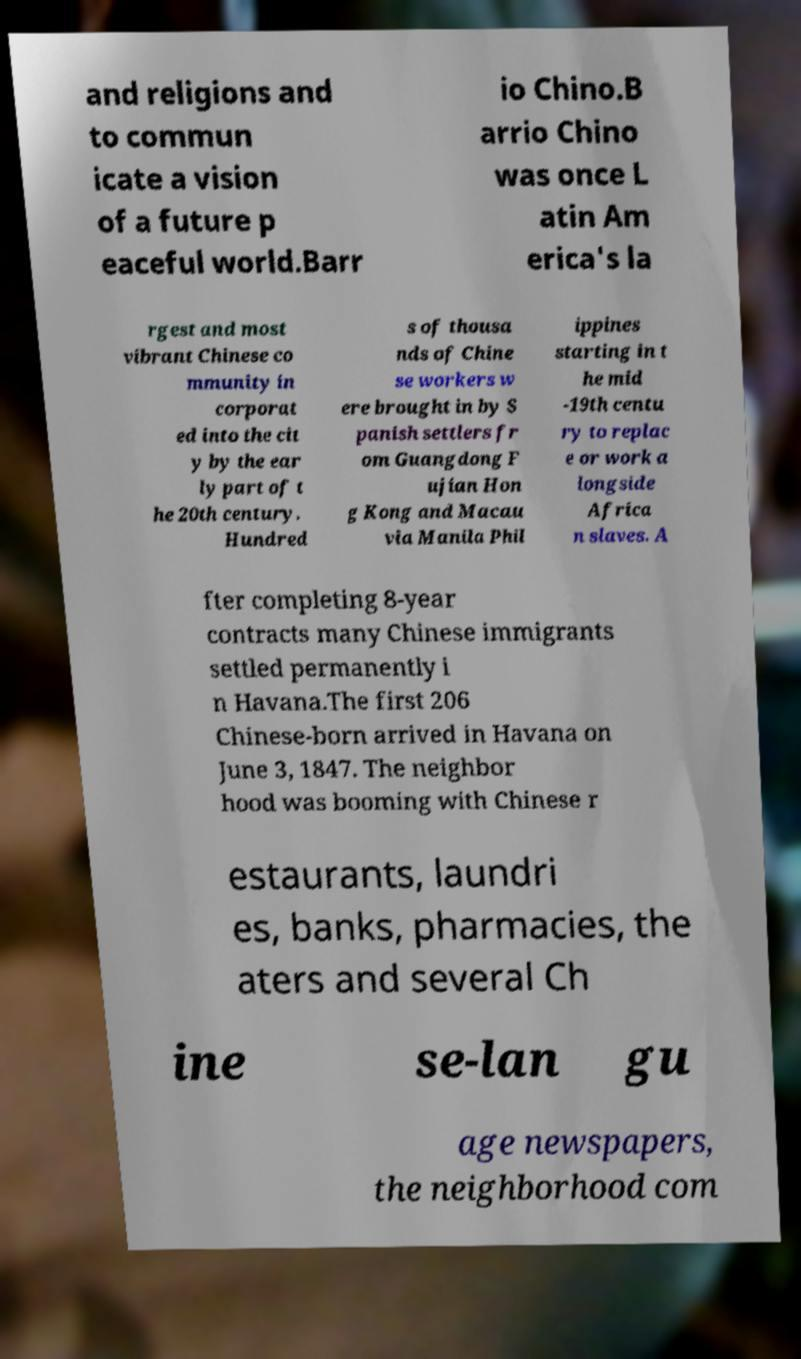I need the written content from this picture converted into text. Can you do that? and religions and to commun icate a vision of a future p eaceful world.Barr io Chino.B arrio Chino was once L atin Am erica's la rgest and most vibrant Chinese co mmunity in corporat ed into the cit y by the ear ly part of t he 20th century. Hundred s of thousa nds of Chine se workers w ere brought in by S panish settlers fr om Guangdong F ujian Hon g Kong and Macau via Manila Phil ippines starting in t he mid -19th centu ry to replac e or work a longside Africa n slaves. A fter completing 8-year contracts many Chinese immigrants settled permanently i n Havana.The first 206 Chinese-born arrived in Havana on June 3, 1847. The neighbor hood was booming with Chinese r estaurants, laundri es, banks, pharmacies, the aters and several Ch ine se-lan gu age newspapers, the neighborhood com 